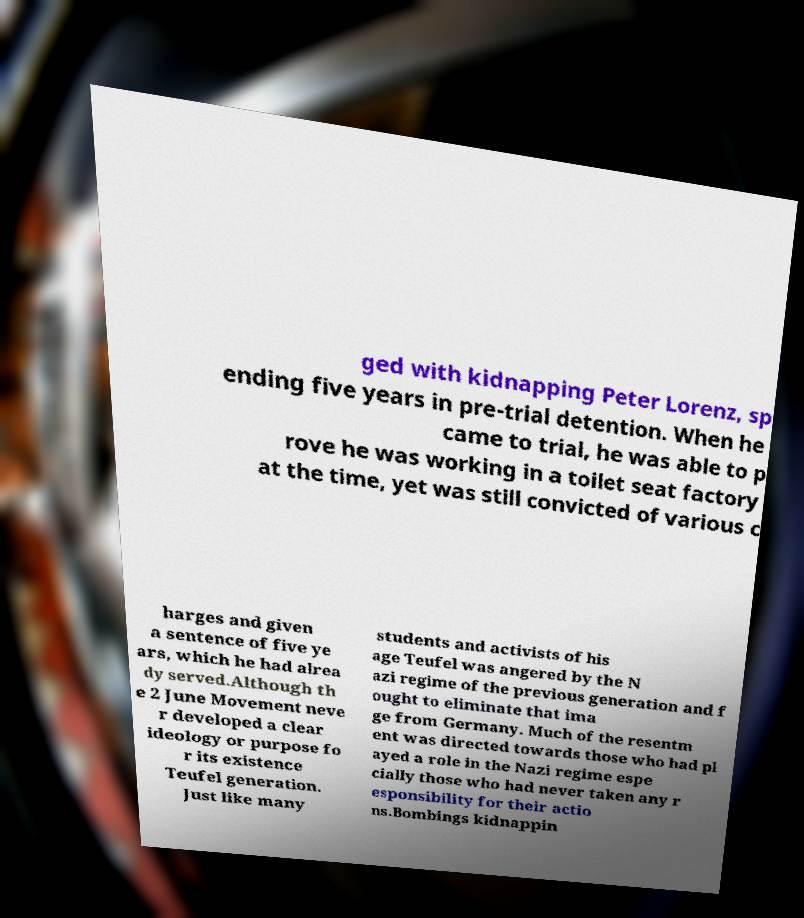I need the written content from this picture converted into text. Can you do that? ged with kidnapping Peter Lorenz, sp ending five years in pre-trial detention. When he came to trial, he was able to p rove he was working in a toilet seat factory at the time, yet was still convicted of various c harges and given a sentence of five ye ars, which he had alrea dy served.Although th e 2 June Movement neve r developed a clear ideology or purpose fo r its existence Teufel generation. Just like many students and activists of his age Teufel was angered by the N azi regime of the previous generation and f ought to eliminate that ima ge from Germany. Much of the resentm ent was directed towards those who had pl ayed a role in the Nazi regime espe cially those who had never taken any r esponsibility for their actio ns.Bombings kidnappin 